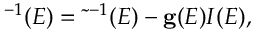Convert formula to latex. <formula><loc_0><loc_0><loc_500><loc_500>{ \tau } ^ { - 1 } ( E ) = \tilde { \tau } ^ { - 1 } ( E ) - { g } ( E ) I ( E ) ,</formula> 